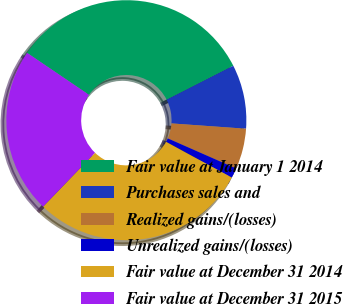<chart> <loc_0><loc_0><loc_500><loc_500><pie_chart><fcel>Fair value at January 1 2014<fcel>Purchases sales and<fcel>Realized gains/(losses)<fcel>Unrealized gains/(losses)<fcel>Fair value at December 31 2014<fcel>Fair value at December 31 2015<nl><fcel>33.02%<fcel>8.63%<fcel>5.46%<fcel>1.34%<fcel>29.26%<fcel>22.28%<nl></chart> 